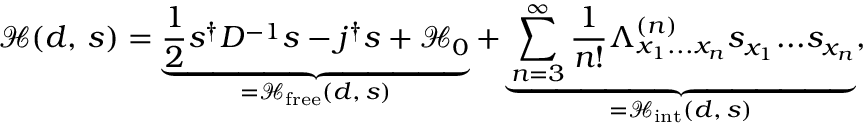Convert formula to latex. <formula><loc_0><loc_0><loc_500><loc_500>{ \mathcal { H } } ( d , \, s ) = \underbrace { { \frac { 1 } { 2 } } s ^ { \dagger } D ^ { - 1 } s - j ^ { \dagger } s + { \mathcal { H } } _ { 0 } } _ { = { \mathcal { H } } _ { f r e e } ( d , \, s ) } + \underbrace { \sum _ { n = 3 } ^ { \infty } { \frac { 1 } { n ! } } \Lambda _ { x _ { 1 } \dots x _ { n } } ^ { ( n ) } s _ { x _ { 1 } } \dots s _ { x _ { n } } } _ { = { \mathcal { H } } _ { i n t } ( d , \, s ) } ,</formula> 